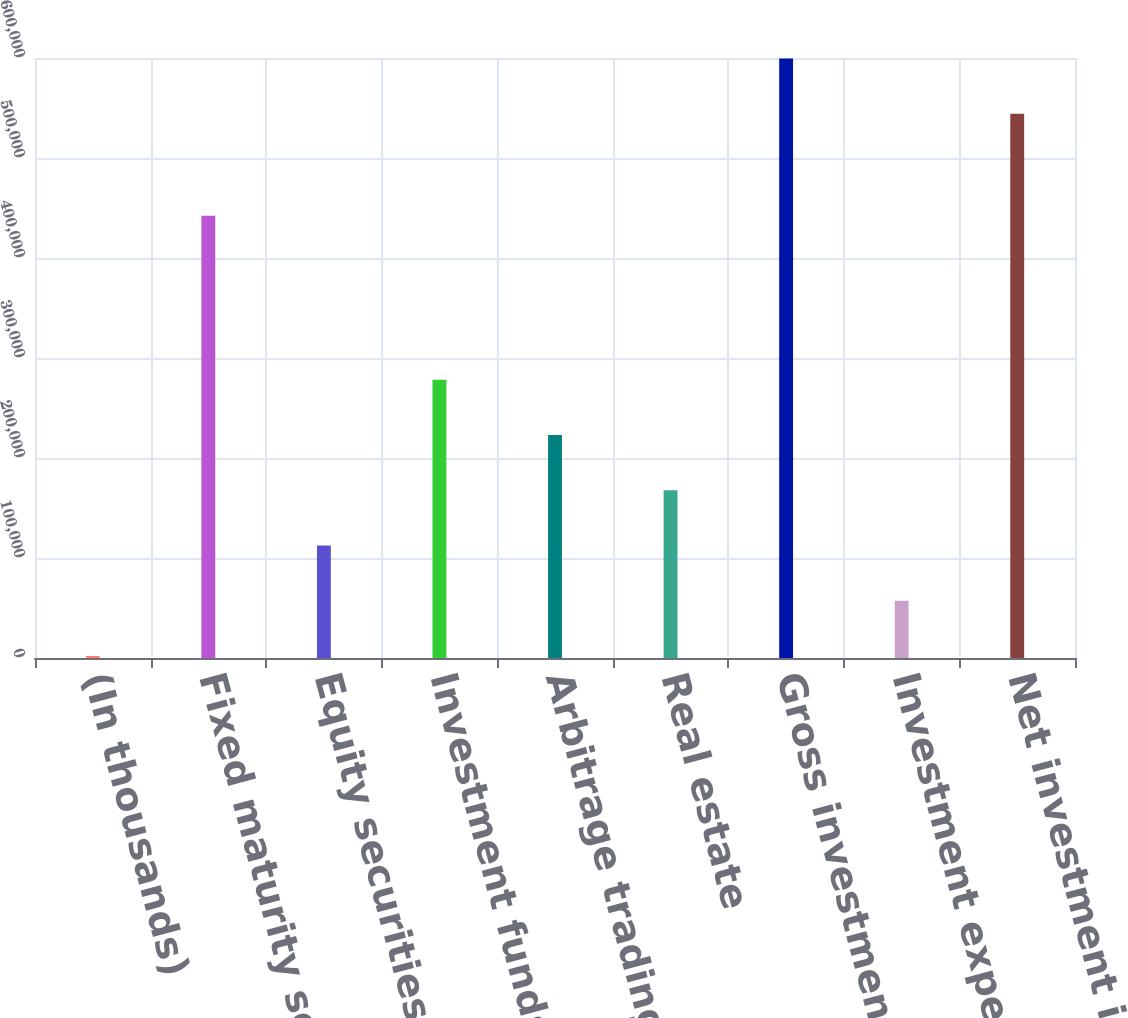Convert chart. <chart><loc_0><loc_0><loc_500><loc_500><bar_chart><fcel>(In thousands)<fcel>Fixed maturity securities<fcel>Equity securities available<fcel>Investment funds<fcel>Arbitrage trading account<fcel>Real estate<fcel>Gross investment income<fcel>Investment expense<fcel>Net investment income<nl><fcel>2013<fcel>442287<fcel>112472<fcel>278160<fcel>222931<fcel>167702<fcel>599520<fcel>57242.5<fcel>544291<nl></chart> 